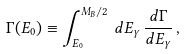<formula> <loc_0><loc_0><loc_500><loc_500>\Gamma ( E _ { 0 } ) \equiv \int _ { E _ { 0 } } ^ { M _ { B } / 2 } \, d E _ { \gamma } \, \frac { d \Gamma } { d E _ { \gamma } } \, ,</formula> 